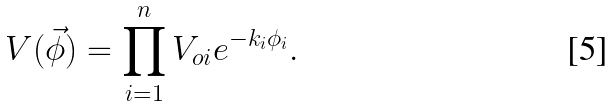<formula> <loc_0><loc_0><loc_500><loc_500>V ( \vec { \phi } ) = \prod _ { i = 1 } ^ { n } V _ { o i } e ^ { - k _ { i } \phi _ { i } } .</formula> 